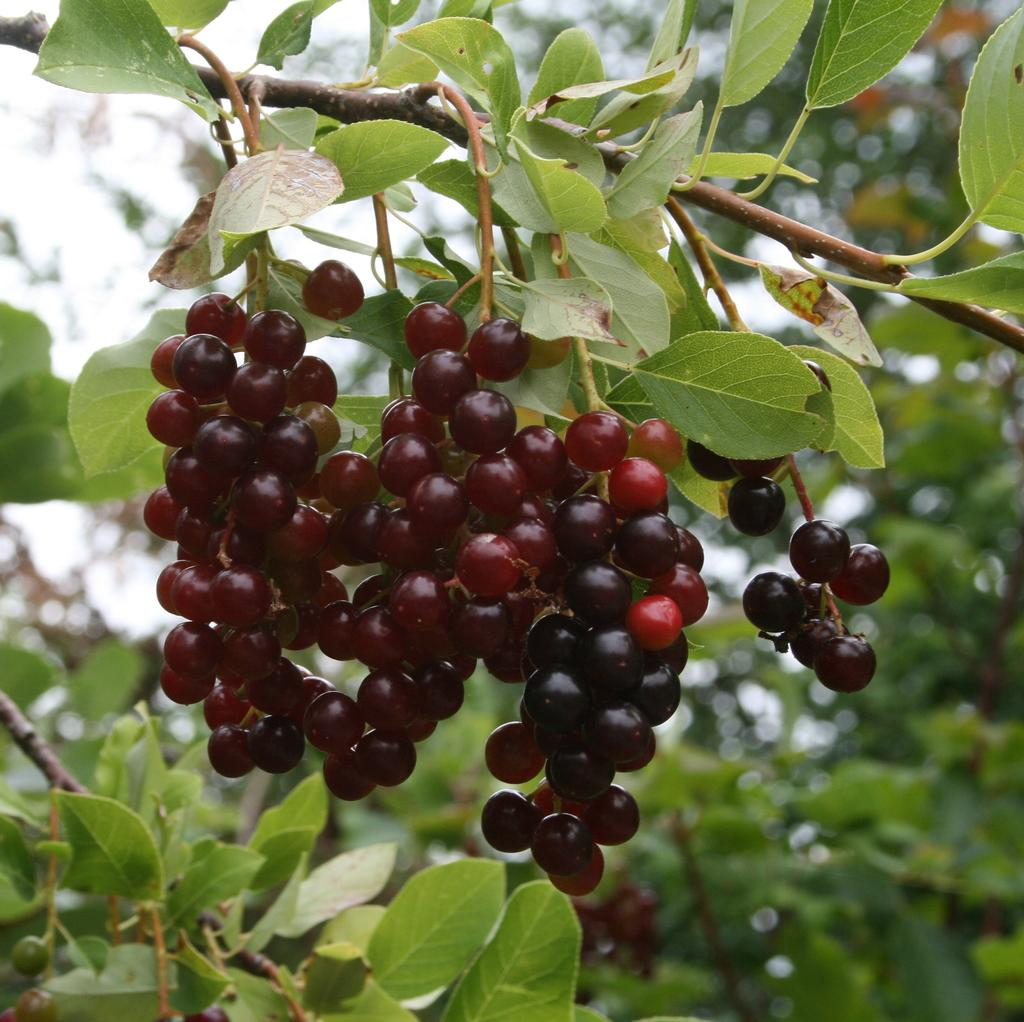What type of vegetation can be seen in the image? There are trees in the image. What type of fruit is visible in the image? There are cherries in the image. What is visible in the background of the image? There is a sky visible in the background of the image. What is the temper of the duck in the image? There is no duck present in the image, so it is not possible to determine its temper. 